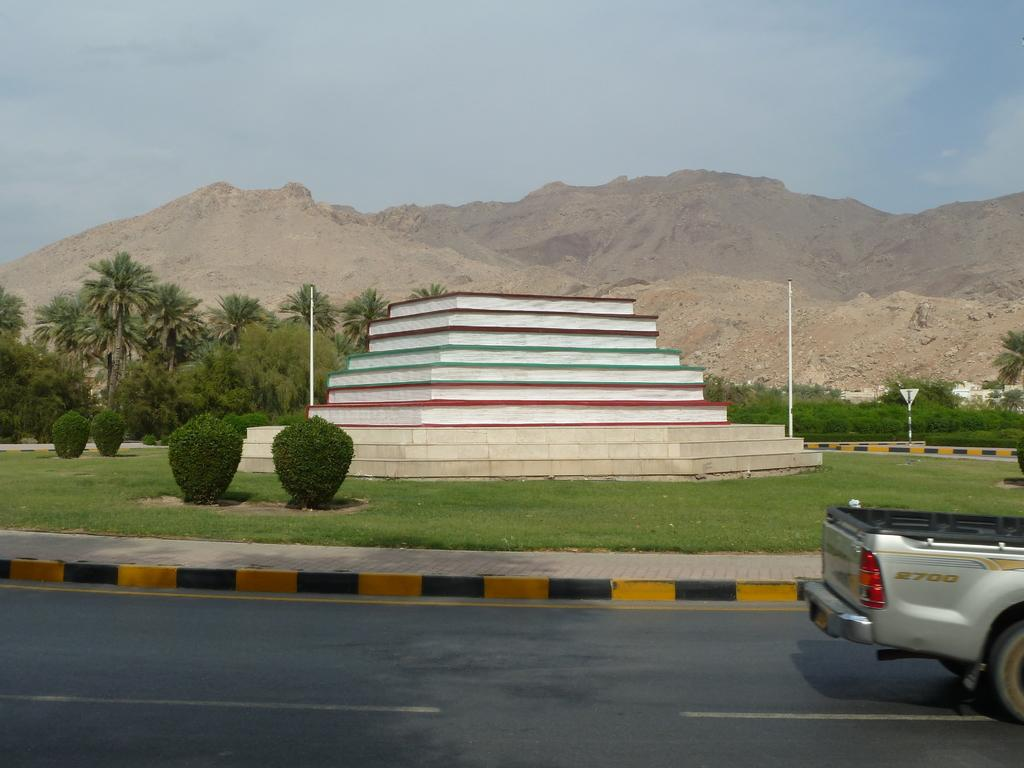<image>
Summarize the visual content of the image. An S2700 pickup truck is driving down the road past a monument. 